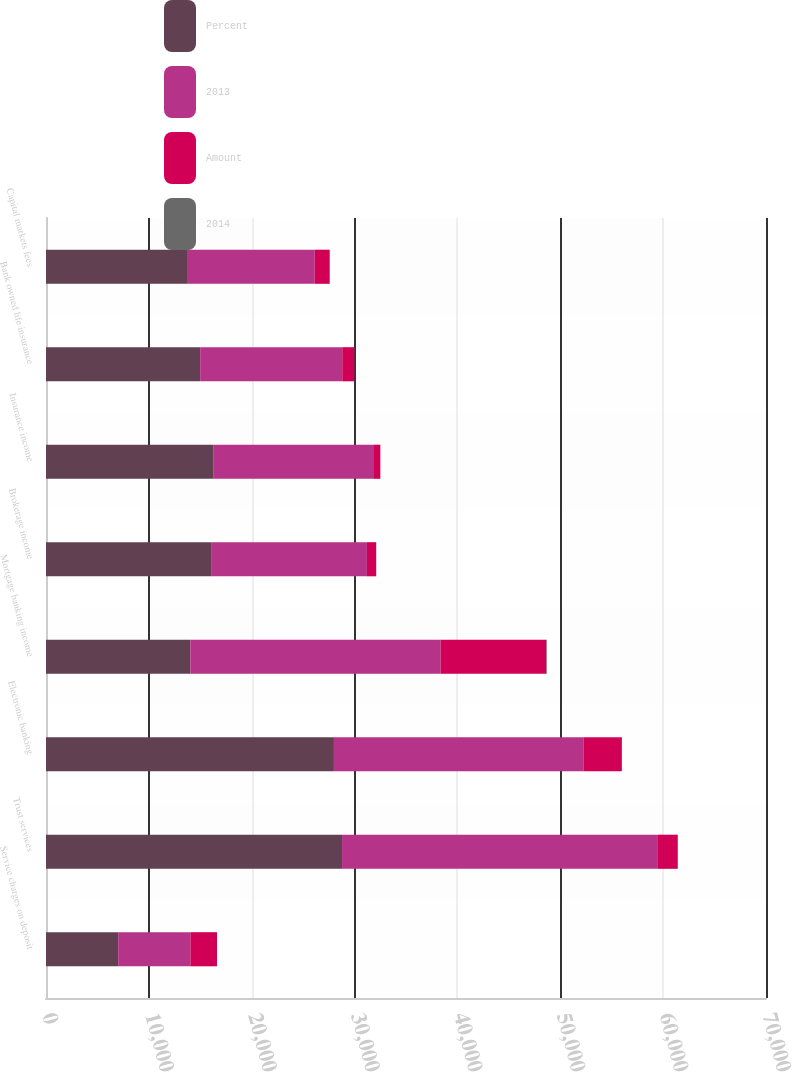<chart> <loc_0><loc_0><loc_500><loc_500><stacked_bar_chart><ecel><fcel>Service charges on deposit<fcel>Trust services<fcel>Electronic banking<fcel>Mortgage banking income<fcel>Brokerage income<fcel>Insurance income<fcel>Bank owned life insurance<fcel>Capital markets fees<nl><fcel>Percent<fcel>7019.5<fcel>28781<fcel>27993<fcel>14030<fcel>16050<fcel>16252<fcel>14988<fcel>13791<nl><fcel>2013<fcel>7019.5<fcel>30711<fcel>24251<fcel>24327<fcel>15151<fcel>15556<fcel>13816<fcel>12332<nl><fcel>Amount<fcel>2584<fcel>1930<fcel>3742<fcel>10297<fcel>899<fcel>696<fcel>1172<fcel>1459<nl><fcel>2014<fcel>4<fcel>6<fcel>15<fcel>42<fcel>6<fcel>4<fcel>8<fcel>12<nl></chart> 